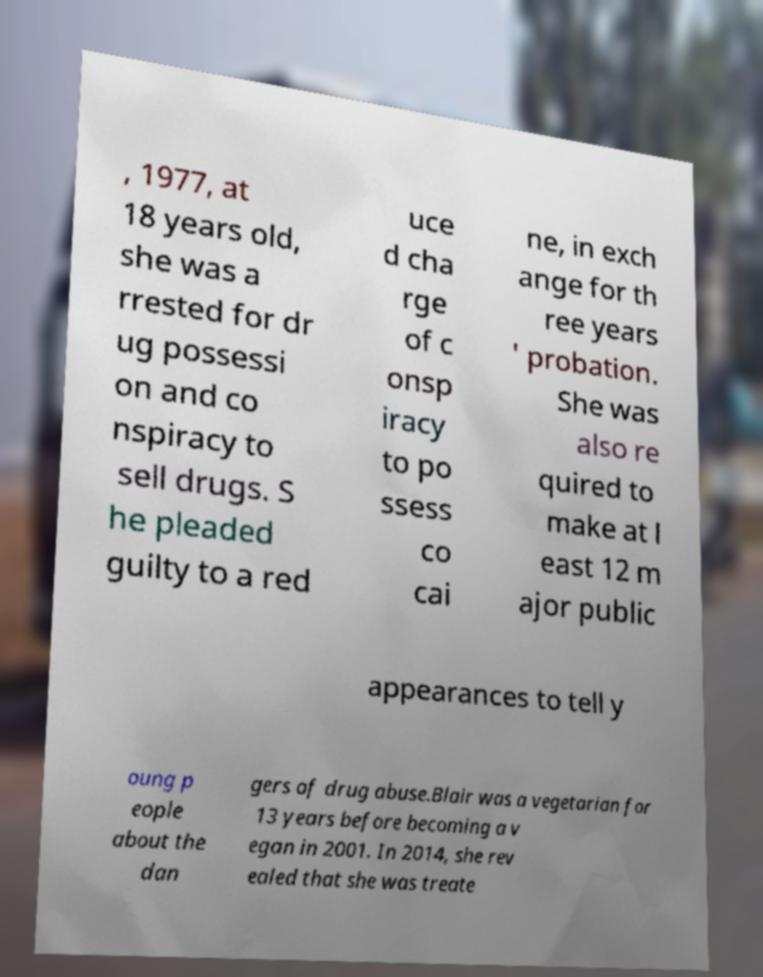Could you extract and type out the text from this image? , 1977, at 18 years old, she was a rrested for dr ug possessi on and co nspiracy to sell drugs. S he pleaded guilty to a red uce d cha rge of c onsp iracy to po ssess co cai ne, in exch ange for th ree years ' probation. She was also re quired to make at l east 12 m ajor public appearances to tell y oung p eople about the dan gers of drug abuse.Blair was a vegetarian for 13 years before becoming a v egan in 2001. In 2014, she rev ealed that she was treate 